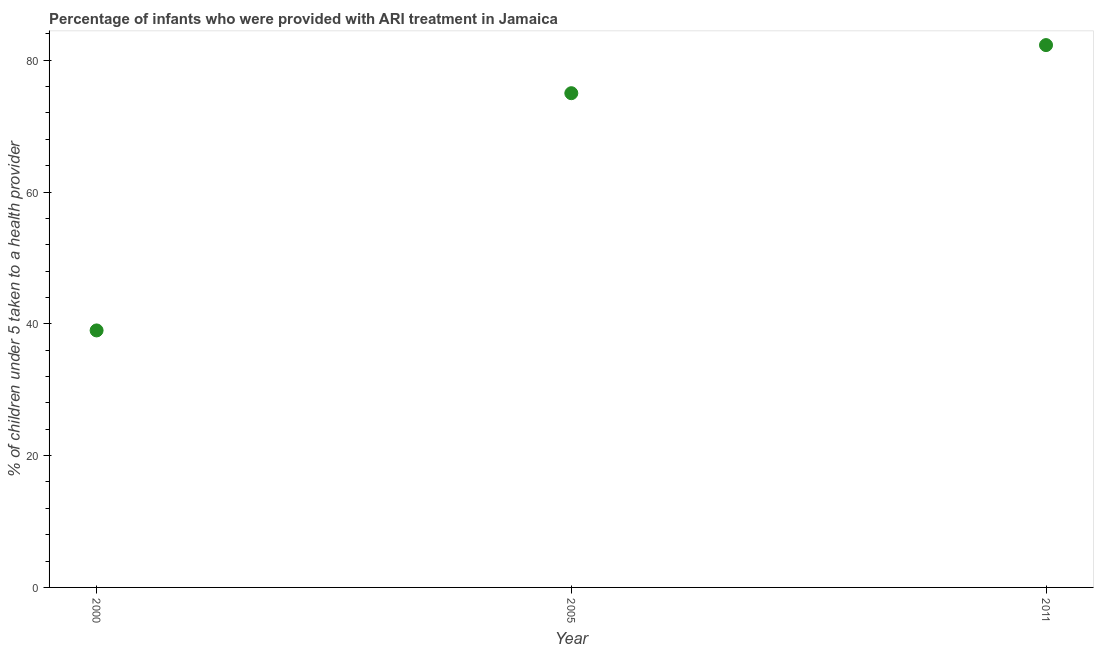Across all years, what is the maximum percentage of children who were provided with ari treatment?
Ensure brevity in your answer.  82.3. In which year was the percentage of children who were provided with ari treatment maximum?
Provide a succinct answer. 2011. What is the sum of the percentage of children who were provided with ari treatment?
Your answer should be very brief. 196.3. What is the difference between the percentage of children who were provided with ari treatment in 2000 and 2005?
Your answer should be compact. -36. What is the average percentage of children who were provided with ari treatment per year?
Offer a very short reply. 65.43. What is the ratio of the percentage of children who were provided with ari treatment in 2005 to that in 2011?
Offer a terse response. 0.91. Is the difference between the percentage of children who were provided with ari treatment in 2000 and 2005 greater than the difference between any two years?
Make the answer very short. No. What is the difference between the highest and the second highest percentage of children who were provided with ari treatment?
Your answer should be compact. 7.3. What is the difference between the highest and the lowest percentage of children who were provided with ari treatment?
Your answer should be very brief. 43.3. What is the difference between two consecutive major ticks on the Y-axis?
Your answer should be compact. 20. Are the values on the major ticks of Y-axis written in scientific E-notation?
Ensure brevity in your answer.  No. Does the graph contain any zero values?
Keep it short and to the point. No. What is the title of the graph?
Offer a terse response. Percentage of infants who were provided with ARI treatment in Jamaica. What is the label or title of the Y-axis?
Ensure brevity in your answer.  % of children under 5 taken to a health provider. What is the % of children under 5 taken to a health provider in 2000?
Offer a terse response. 39. What is the % of children under 5 taken to a health provider in 2011?
Offer a terse response. 82.3. What is the difference between the % of children under 5 taken to a health provider in 2000 and 2005?
Your response must be concise. -36. What is the difference between the % of children under 5 taken to a health provider in 2000 and 2011?
Offer a terse response. -43.3. What is the ratio of the % of children under 5 taken to a health provider in 2000 to that in 2005?
Your answer should be compact. 0.52. What is the ratio of the % of children under 5 taken to a health provider in 2000 to that in 2011?
Offer a very short reply. 0.47. What is the ratio of the % of children under 5 taken to a health provider in 2005 to that in 2011?
Your answer should be very brief. 0.91. 